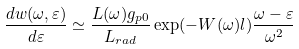<formula> <loc_0><loc_0><loc_500><loc_500>\frac { d w ( \omega , \varepsilon ) } { d \varepsilon } \simeq \frac { L ( \omega ) g _ { p 0 } } { L _ { r a d } } \exp ( - W ( \omega ) l ) \frac { \omega - \varepsilon } { \omega ^ { 2 } }</formula> 